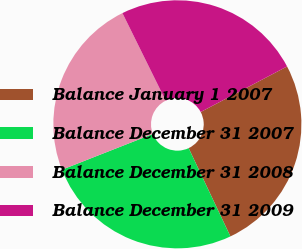<chart> <loc_0><loc_0><loc_500><loc_500><pie_chart><fcel>Balance January 1 2007<fcel>Balance December 31 2007<fcel>Balance December 31 2008<fcel>Balance December 31 2009<nl><fcel>25.69%<fcel>26.07%<fcel>23.66%<fcel>24.58%<nl></chart> 